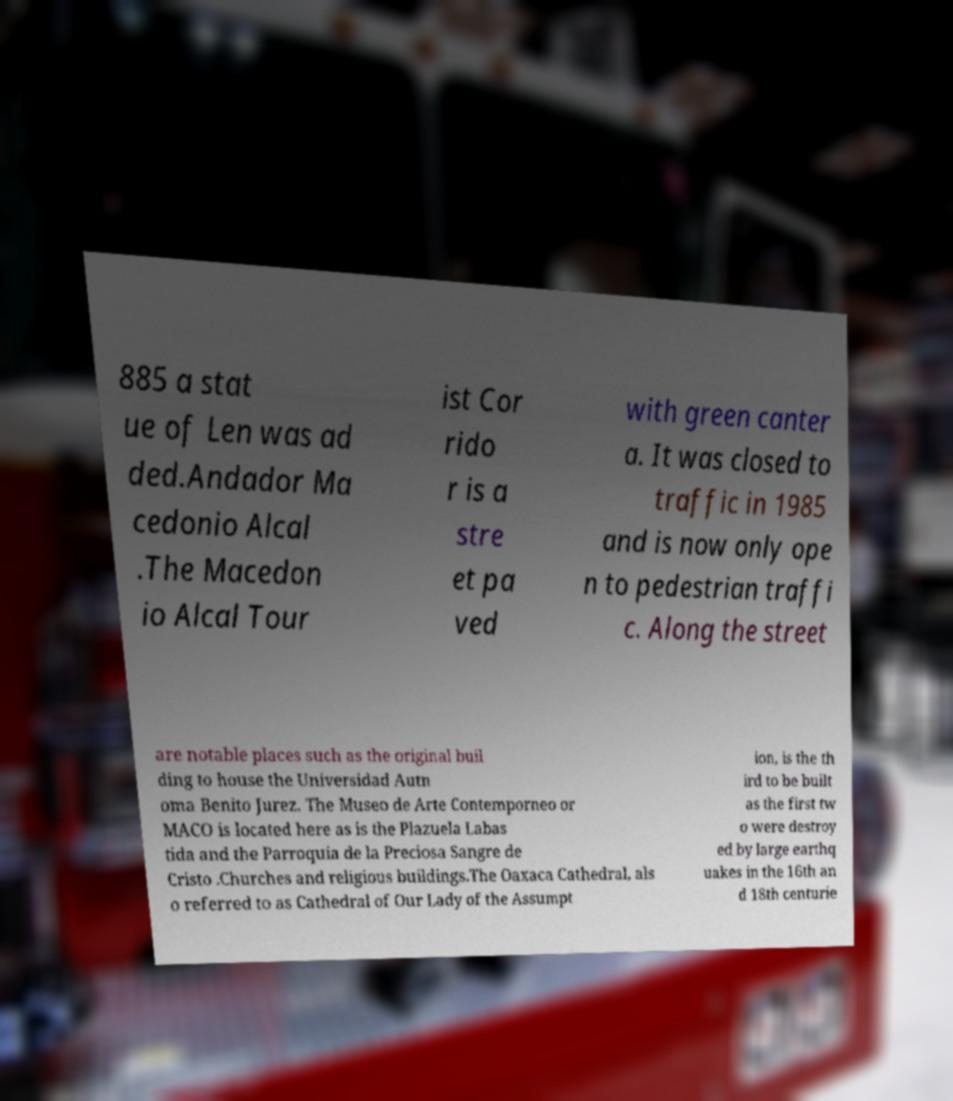I need the written content from this picture converted into text. Can you do that? 885 a stat ue of Len was ad ded.Andador Ma cedonio Alcal .The Macedon io Alcal Tour ist Cor rido r is a stre et pa ved with green canter a. It was closed to traffic in 1985 and is now only ope n to pedestrian traffi c. Along the street are notable places such as the original buil ding to house the Universidad Autn oma Benito Jurez. The Museo de Arte Contemporneo or MACO is located here as is the Plazuela Labas tida and the Parroquia de la Preciosa Sangre de Cristo .Churches and religious buildings.The Oaxaca Cathedral, als o referred to as Cathedral of Our Lady of the Assumpt ion, is the th ird to be built as the first tw o were destroy ed by large earthq uakes in the 16th an d 18th centurie 